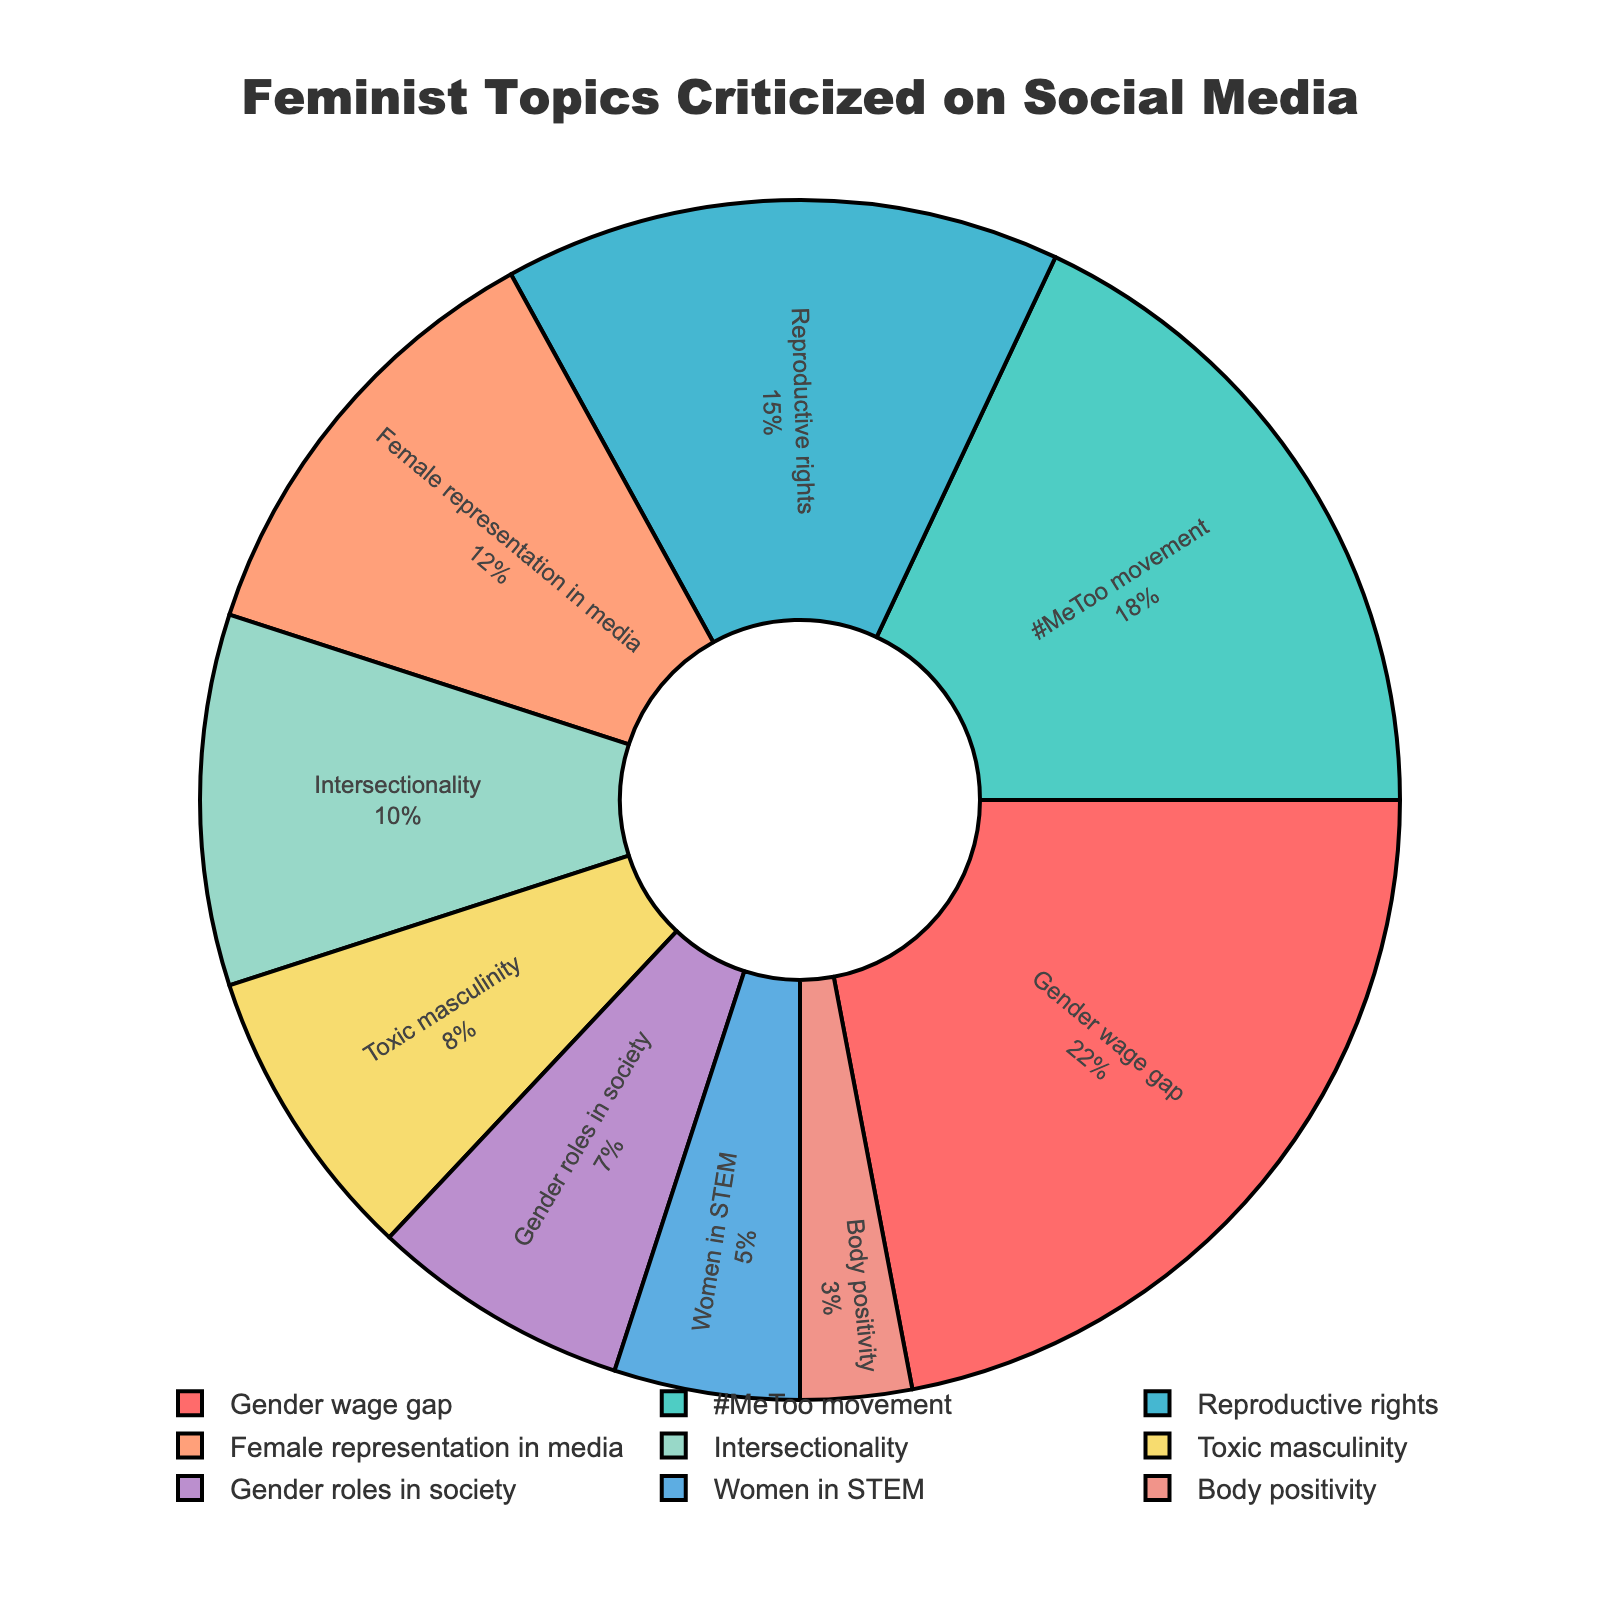Which feminist-related topic is most frequently criticized on social media? The pie chart shows several feminist-related topics along with their percentages. The largest slice represents the topic with the highest percentage.
Answer: Gender wage gap What percentage of criticisms are directed at the #MeToo movement? The pie chart includes the percentages for each feminist-related topic. Locate the label for the #MeToo movement and read the percentage next to it.
Answer: 18% Is the percentage of criticisms for Reproductive rights greater than or less than the percentage for Female representation in media? Compare the slices labeled Reproductive rights and Female representation in media. The percentage for Reproductive rights is 15%, and the percentage for Female representation in media is 12%.
Answer: Greater What is the combined percentage of criticisms for Intersectionality and Toxic masculinity? Add the percentages of Intersectionality (10%) and Toxic masculinity (8%) together. 10% + 8% = 18%
Answer: 18% Which topic has the smallest percentage of criticisms, and what is that percentage? The smallest slice on the pie chart represents the topic with the lowest percentage. Locate this slice and read the label and percentage.
Answer: Body positivity, 3% How much more frequently is the Gender wage gap criticized compared to Women in STEM? Subtract the percentage for Women in STEM (5%) from the percentage for the Gender wage gap (22%). 22% - 5% = 17%
Answer: 17% more Name two topics that together account for more than 30% of the criticisms. Look for two slices whose combined percentages exceed 30%. For instance, Gender wage gap (22%) and #MeToo movement (18%) together account for 40%.
Answer: Gender wage gap and #MeToo movement How many topics have less than 10% criticism each? Count the slices with percentages below 10%. There are four such slices: Intersectionality (10%), Toxic masculinity (8%), Gender roles in society (7%), and Body positivity (3%).
Answer: 4 topics What is the total percentage of criticisms for topics related to gender roles (Gender roles in society and Toxic masculinity)? Add the percentages for Gender roles in society (7%) and Toxic masculinity (8%). 7% + 8% = 15%
Answer: 15% Which topic has a higher criticism percentage, Women in STEM or Body positivity, and by how much? Subtract the percentage of Body positivity (3%) from Women in STEM (5%). 5% - 3% = 2%. Women in STEM has a higher percentage.
Answer: Women in STEM by 2% 